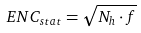Convert formula to latex. <formula><loc_0><loc_0><loc_500><loc_500>E N C _ { s t a t } = \sqrt { N _ { h } \cdot f }</formula> 